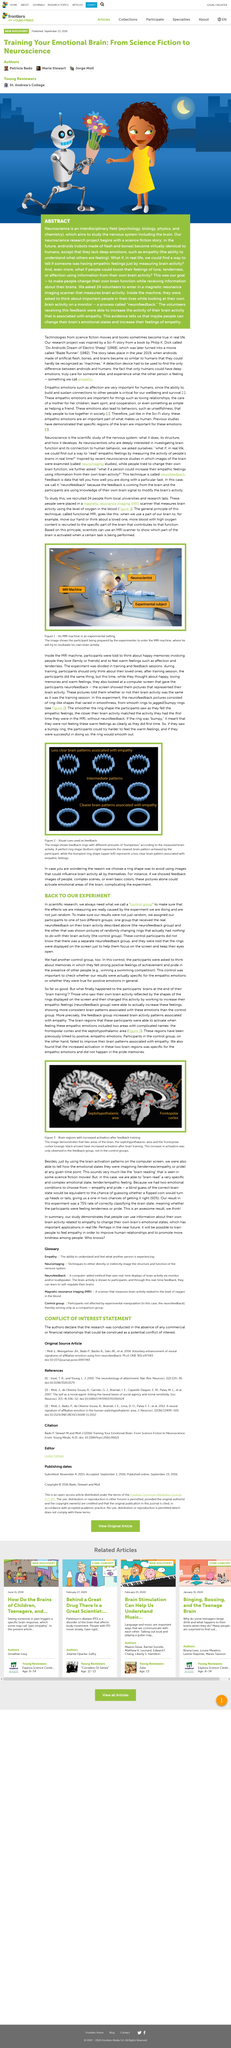Draw attention to some important aspects in this diagram. Yes, the experiment described by the author involves neurofeedback. The two groups in the experiment were named as the "neurofeedback group" and the "control group". A control group is always required in scientific research, as it is a fundamental component of experimental design. 